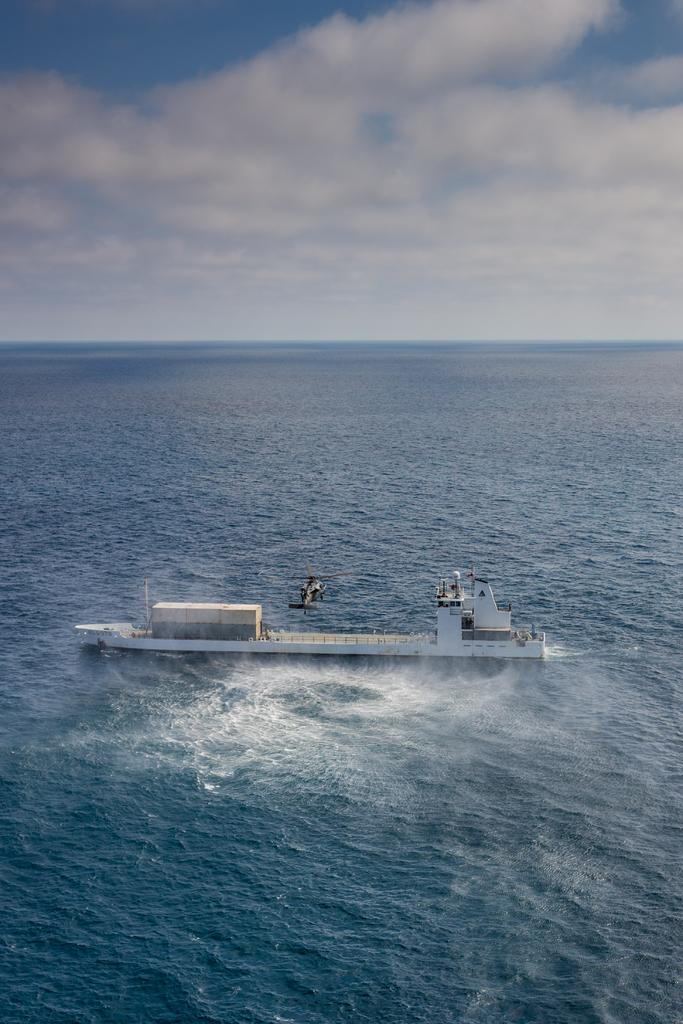What can be seen in the sky in the image? The sky is visible in the image, and there are clouds in the sky. What type of vehicle is present in the image? There is a helicopter in the image. What is the ship's location in the image? The ship is on the sea in the image. What is the primary mode of transportation for the ship? The ship is on the sea, which suggests it is a water-based mode of transportation. What type of wax can be seen melting on the plate in the image? There is no plate or wax present in the image; it features a sky with clouds, a helicopter, and a ship on the sea. 